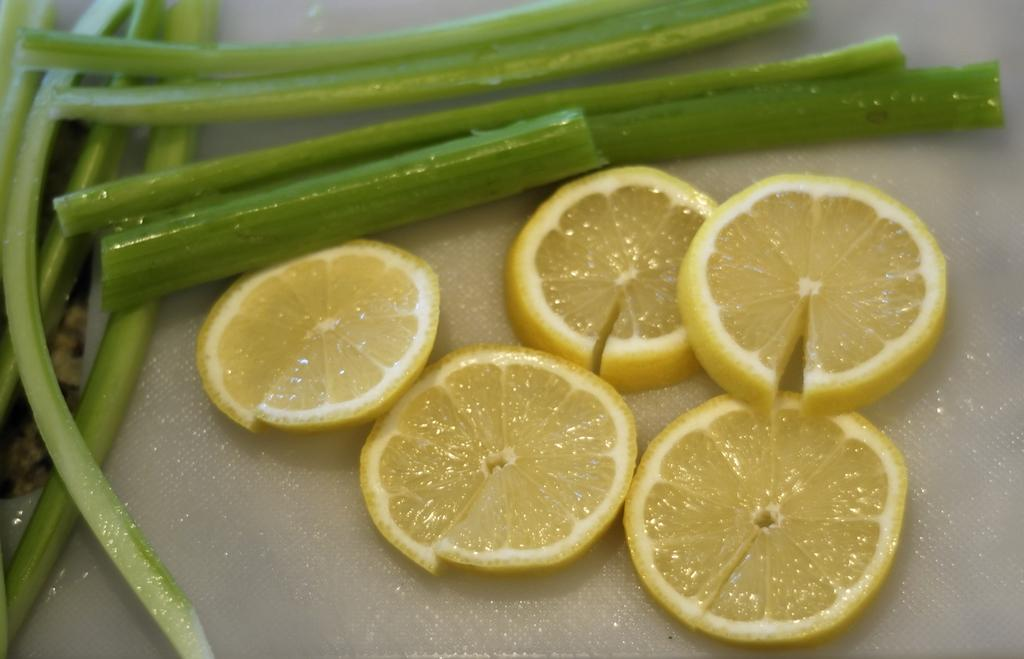What is on the plate in the image? There are lemons on the plate in the image. What else can be seen in the image besides the plate and lemons? There are stems in the image. How many rabbits can be seen playing with the ghost in the image? There are no rabbits or ghosts present in the image; it only features a plate with lemons and stems. 